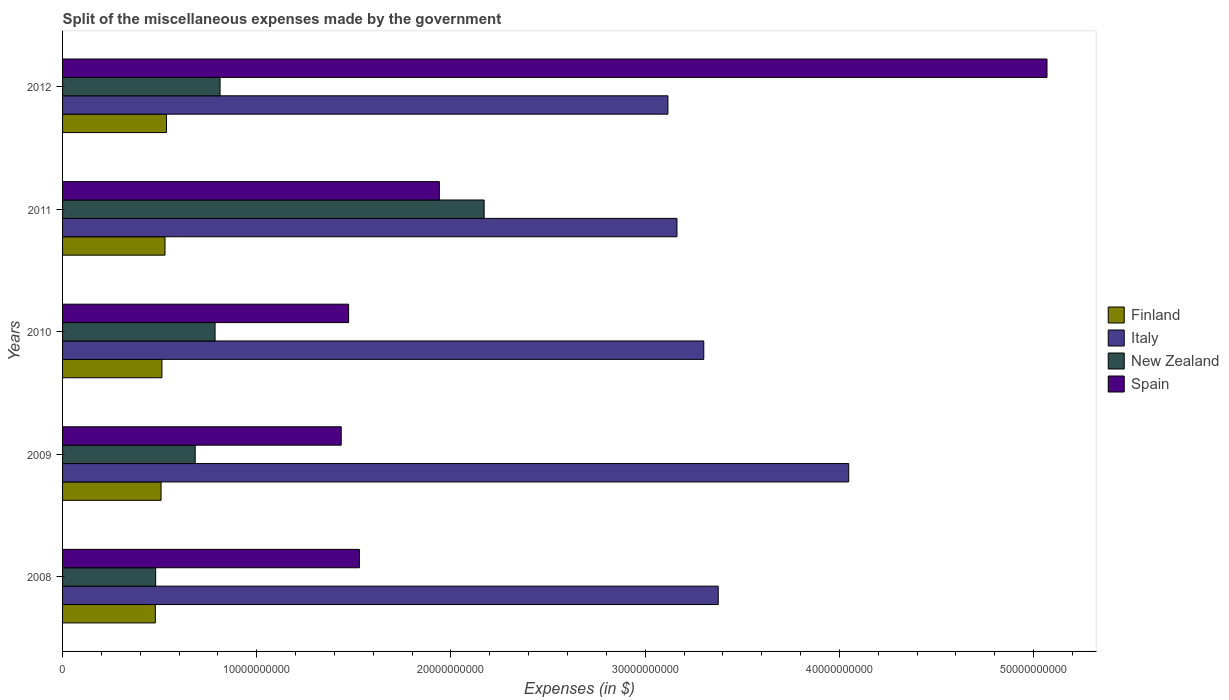How many different coloured bars are there?
Your answer should be compact. 4. How many groups of bars are there?
Your answer should be very brief. 5. Are the number of bars on each tick of the Y-axis equal?
Ensure brevity in your answer.  Yes. How many bars are there on the 1st tick from the top?
Offer a very short reply. 4. How many bars are there on the 3rd tick from the bottom?
Offer a terse response. 4. What is the label of the 2nd group of bars from the top?
Offer a terse response. 2011. What is the miscellaneous expenses made by the government in Italy in 2011?
Ensure brevity in your answer.  3.16e+1. Across all years, what is the maximum miscellaneous expenses made by the government in Spain?
Provide a short and direct response. 5.07e+1. Across all years, what is the minimum miscellaneous expenses made by the government in New Zealand?
Provide a succinct answer. 4.79e+09. What is the total miscellaneous expenses made by the government in Italy in the graph?
Offer a terse response. 1.70e+11. What is the difference between the miscellaneous expenses made by the government in Finland in 2008 and that in 2012?
Your response must be concise. -5.75e+08. What is the difference between the miscellaneous expenses made by the government in Italy in 2010 and the miscellaneous expenses made by the government in Finland in 2009?
Keep it short and to the point. 2.79e+1. What is the average miscellaneous expenses made by the government in New Zealand per year?
Offer a very short reply. 9.86e+09. In the year 2012, what is the difference between the miscellaneous expenses made by the government in Spain and miscellaneous expenses made by the government in New Zealand?
Your answer should be compact. 4.26e+1. What is the ratio of the miscellaneous expenses made by the government in Finland in 2010 to that in 2012?
Your answer should be compact. 0.96. Is the miscellaneous expenses made by the government in Finland in 2010 less than that in 2011?
Ensure brevity in your answer.  Yes. What is the difference between the highest and the second highest miscellaneous expenses made by the government in New Zealand?
Give a very brief answer. 1.36e+1. What is the difference between the highest and the lowest miscellaneous expenses made by the government in Spain?
Make the answer very short. 3.63e+1. Is the sum of the miscellaneous expenses made by the government in Spain in 2008 and 2011 greater than the maximum miscellaneous expenses made by the government in New Zealand across all years?
Your response must be concise. Yes. What does the 2nd bar from the top in 2008 represents?
Give a very brief answer. New Zealand. Is it the case that in every year, the sum of the miscellaneous expenses made by the government in Spain and miscellaneous expenses made by the government in Finland is greater than the miscellaneous expenses made by the government in Italy?
Keep it short and to the point. No. How many years are there in the graph?
Provide a short and direct response. 5. What is the difference between two consecutive major ticks on the X-axis?
Give a very brief answer. 1.00e+1. Are the values on the major ticks of X-axis written in scientific E-notation?
Ensure brevity in your answer.  No. Does the graph contain grids?
Keep it short and to the point. No. How many legend labels are there?
Give a very brief answer. 4. What is the title of the graph?
Your answer should be compact. Split of the miscellaneous expenses made by the government. What is the label or title of the X-axis?
Give a very brief answer. Expenses (in $). What is the Expenses (in $) in Finland in 2008?
Offer a very short reply. 4.78e+09. What is the Expenses (in $) of Italy in 2008?
Your answer should be compact. 3.38e+1. What is the Expenses (in $) of New Zealand in 2008?
Your answer should be very brief. 4.79e+09. What is the Expenses (in $) of Spain in 2008?
Provide a succinct answer. 1.53e+1. What is the Expenses (in $) of Finland in 2009?
Provide a short and direct response. 5.07e+09. What is the Expenses (in $) of Italy in 2009?
Offer a terse response. 4.05e+1. What is the Expenses (in $) of New Zealand in 2009?
Your answer should be compact. 6.83e+09. What is the Expenses (in $) of Spain in 2009?
Your response must be concise. 1.43e+1. What is the Expenses (in $) in Finland in 2010?
Your response must be concise. 5.12e+09. What is the Expenses (in $) in Italy in 2010?
Your answer should be compact. 3.30e+1. What is the Expenses (in $) of New Zealand in 2010?
Keep it short and to the point. 7.85e+09. What is the Expenses (in $) in Spain in 2010?
Your answer should be compact. 1.47e+1. What is the Expenses (in $) in Finland in 2011?
Make the answer very short. 5.28e+09. What is the Expenses (in $) in Italy in 2011?
Give a very brief answer. 3.16e+1. What is the Expenses (in $) of New Zealand in 2011?
Keep it short and to the point. 2.17e+1. What is the Expenses (in $) in Spain in 2011?
Ensure brevity in your answer.  1.94e+1. What is the Expenses (in $) of Finland in 2012?
Your answer should be compact. 5.35e+09. What is the Expenses (in $) in Italy in 2012?
Your answer should be compact. 3.12e+1. What is the Expenses (in $) of New Zealand in 2012?
Offer a very short reply. 8.11e+09. What is the Expenses (in $) in Spain in 2012?
Offer a terse response. 5.07e+1. Across all years, what is the maximum Expenses (in $) in Finland?
Offer a very short reply. 5.35e+09. Across all years, what is the maximum Expenses (in $) in Italy?
Give a very brief answer. 4.05e+1. Across all years, what is the maximum Expenses (in $) in New Zealand?
Give a very brief answer. 2.17e+1. Across all years, what is the maximum Expenses (in $) in Spain?
Make the answer very short. 5.07e+1. Across all years, what is the minimum Expenses (in $) in Finland?
Your answer should be very brief. 4.78e+09. Across all years, what is the minimum Expenses (in $) of Italy?
Your answer should be compact. 3.12e+1. Across all years, what is the minimum Expenses (in $) of New Zealand?
Provide a succinct answer. 4.79e+09. Across all years, what is the minimum Expenses (in $) in Spain?
Ensure brevity in your answer.  1.43e+1. What is the total Expenses (in $) of Finland in the graph?
Provide a short and direct response. 2.56e+1. What is the total Expenses (in $) in Italy in the graph?
Your answer should be very brief. 1.70e+11. What is the total Expenses (in $) in New Zealand in the graph?
Offer a very short reply. 4.93e+1. What is the total Expenses (in $) of Spain in the graph?
Your answer should be compact. 1.14e+11. What is the difference between the Expenses (in $) of Finland in 2008 and that in 2009?
Provide a short and direct response. -2.94e+08. What is the difference between the Expenses (in $) of Italy in 2008 and that in 2009?
Give a very brief answer. -6.72e+09. What is the difference between the Expenses (in $) of New Zealand in 2008 and that in 2009?
Make the answer very short. -2.04e+09. What is the difference between the Expenses (in $) in Spain in 2008 and that in 2009?
Your response must be concise. 9.39e+08. What is the difference between the Expenses (in $) of Finland in 2008 and that in 2010?
Offer a very short reply. -3.39e+08. What is the difference between the Expenses (in $) in Italy in 2008 and that in 2010?
Offer a terse response. 7.45e+08. What is the difference between the Expenses (in $) of New Zealand in 2008 and that in 2010?
Give a very brief answer. -3.06e+09. What is the difference between the Expenses (in $) of Spain in 2008 and that in 2010?
Your answer should be compact. 5.57e+08. What is the difference between the Expenses (in $) in Finland in 2008 and that in 2011?
Provide a succinct answer. -4.97e+08. What is the difference between the Expenses (in $) in Italy in 2008 and that in 2011?
Your answer should be compact. 2.12e+09. What is the difference between the Expenses (in $) in New Zealand in 2008 and that in 2011?
Your answer should be compact. -1.69e+1. What is the difference between the Expenses (in $) in Spain in 2008 and that in 2011?
Provide a succinct answer. -4.12e+09. What is the difference between the Expenses (in $) in Finland in 2008 and that in 2012?
Offer a terse response. -5.75e+08. What is the difference between the Expenses (in $) of Italy in 2008 and that in 2012?
Keep it short and to the point. 2.59e+09. What is the difference between the Expenses (in $) of New Zealand in 2008 and that in 2012?
Give a very brief answer. -3.32e+09. What is the difference between the Expenses (in $) of Spain in 2008 and that in 2012?
Provide a succinct answer. -3.54e+1. What is the difference between the Expenses (in $) in Finland in 2009 and that in 2010?
Give a very brief answer. -4.50e+07. What is the difference between the Expenses (in $) in Italy in 2009 and that in 2010?
Give a very brief answer. 7.46e+09. What is the difference between the Expenses (in $) in New Zealand in 2009 and that in 2010?
Provide a short and direct response. -1.02e+09. What is the difference between the Expenses (in $) of Spain in 2009 and that in 2010?
Offer a very short reply. -3.82e+08. What is the difference between the Expenses (in $) of Finland in 2009 and that in 2011?
Make the answer very short. -2.03e+08. What is the difference between the Expenses (in $) in Italy in 2009 and that in 2011?
Offer a very short reply. 8.84e+09. What is the difference between the Expenses (in $) in New Zealand in 2009 and that in 2011?
Your response must be concise. -1.49e+1. What is the difference between the Expenses (in $) of Spain in 2009 and that in 2011?
Provide a succinct answer. -5.06e+09. What is the difference between the Expenses (in $) of Finland in 2009 and that in 2012?
Provide a succinct answer. -2.81e+08. What is the difference between the Expenses (in $) in Italy in 2009 and that in 2012?
Your response must be concise. 9.31e+09. What is the difference between the Expenses (in $) of New Zealand in 2009 and that in 2012?
Your answer should be compact. -1.28e+09. What is the difference between the Expenses (in $) in Spain in 2009 and that in 2012?
Provide a short and direct response. -3.63e+1. What is the difference between the Expenses (in $) in Finland in 2010 and that in 2011?
Offer a terse response. -1.58e+08. What is the difference between the Expenses (in $) in Italy in 2010 and that in 2011?
Give a very brief answer. 1.38e+09. What is the difference between the Expenses (in $) in New Zealand in 2010 and that in 2011?
Ensure brevity in your answer.  -1.39e+1. What is the difference between the Expenses (in $) in Spain in 2010 and that in 2011?
Provide a short and direct response. -4.67e+09. What is the difference between the Expenses (in $) of Finland in 2010 and that in 2012?
Keep it short and to the point. -2.36e+08. What is the difference between the Expenses (in $) of Italy in 2010 and that in 2012?
Your answer should be very brief. 1.85e+09. What is the difference between the Expenses (in $) in New Zealand in 2010 and that in 2012?
Your response must be concise. -2.58e+08. What is the difference between the Expenses (in $) in Spain in 2010 and that in 2012?
Ensure brevity in your answer.  -3.60e+1. What is the difference between the Expenses (in $) of Finland in 2011 and that in 2012?
Your answer should be compact. -7.80e+07. What is the difference between the Expenses (in $) of Italy in 2011 and that in 2012?
Ensure brevity in your answer.  4.66e+08. What is the difference between the Expenses (in $) in New Zealand in 2011 and that in 2012?
Ensure brevity in your answer.  1.36e+1. What is the difference between the Expenses (in $) in Spain in 2011 and that in 2012?
Ensure brevity in your answer.  -3.13e+1. What is the difference between the Expenses (in $) in Finland in 2008 and the Expenses (in $) in Italy in 2009?
Offer a very short reply. -3.57e+1. What is the difference between the Expenses (in $) in Finland in 2008 and the Expenses (in $) in New Zealand in 2009?
Provide a short and direct response. -2.05e+09. What is the difference between the Expenses (in $) of Finland in 2008 and the Expenses (in $) of Spain in 2009?
Keep it short and to the point. -9.57e+09. What is the difference between the Expenses (in $) in Italy in 2008 and the Expenses (in $) in New Zealand in 2009?
Ensure brevity in your answer.  2.69e+1. What is the difference between the Expenses (in $) in Italy in 2008 and the Expenses (in $) in Spain in 2009?
Make the answer very short. 1.94e+1. What is the difference between the Expenses (in $) in New Zealand in 2008 and the Expenses (in $) in Spain in 2009?
Ensure brevity in your answer.  -9.55e+09. What is the difference between the Expenses (in $) in Finland in 2008 and the Expenses (in $) in Italy in 2010?
Offer a terse response. -2.82e+1. What is the difference between the Expenses (in $) of Finland in 2008 and the Expenses (in $) of New Zealand in 2010?
Make the answer very short. -3.07e+09. What is the difference between the Expenses (in $) in Finland in 2008 and the Expenses (in $) in Spain in 2010?
Make the answer very short. -9.95e+09. What is the difference between the Expenses (in $) of Italy in 2008 and the Expenses (in $) of New Zealand in 2010?
Provide a succinct answer. 2.59e+1. What is the difference between the Expenses (in $) in Italy in 2008 and the Expenses (in $) in Spain in 2010?
Offer a terse response. 1.90e+1. What is the difference between the Expenses (in $) of New Zealand in 2008 and the Expenses (in $) of Spain in 2010?
Your answer should be very brief. -9.94e+09. What is the difference between the Expenses (in $) of Finland in 2008 and the Expenses (in $) of Italy in 2011?
Your response must be concise. -2.69e+1. What is the difference between the Expenses (in $) in Finland in 2008 and the Expenses (in $) in New Zealand in 2011?
Your answer should be compact. -1.69e+1. What is the difference between the Expenses (in $) of Finland in 2008 and the Expenses (in $) of Spain in 2011?
Provide a short and direct response. -1.46e+1. What is the difference between the Expenses (in $) of Italy in 2008 and the Expenses (in $) of New Zealand in 2011?
Keep it short and to the point. 1.21e+1. What is the difference between the Expenses (in $) of Italy in 2008 and the Expenses (in $) of Spain in 2011?
Offer a terse response. 1.44e+1. What is the difference between the Expenses (in $) of New Zealand in 2008 and the Expenses (in $) of Spain in 2011?
Keep it short and to the point. -1.46e+1. What is the difference between the Expenses (in $) in Finland in 2008 and the Expenses (in $) in Italy in 2012?
Give a very brief answer. -2.64e+1. What is the difference between the Expenses (in $) of Finland in 2008 and the Expenses (in $) of New Zealand in 2012?
Keep it short and to the point. -3.33e+09. What is the difference between the Expenses (in $) of Finland in 2008 and the Expenses (in $) of Spain in 2012?
Offer a terse response. -4.59e+1. What is the difference between the Expenses (in $) of Italy in 2008 and the Expenses (in $) of New Zealand in 2012?
Provide a succinct answer. 2.57e+1. What is the difference between the Expenses (in $) of Italy in 2008 and the Expenses (in $) of Spain in 2012?
Provide a short and direct response. -1.69e+1. What is the difference between the Expenses (in $) in New Zealand in 2008 and the Expenses (in $) in Spain in 2012?
Make the answer very short. -4.59e+1. What is the difference between the Expenses (in $) in Finland in 2009 and the Expenses (in $) in Italy in 2010?
Your response must be concise. -2.79e+1. What is the difference between the Expenses (in $) of Finland in 2009 and the Expenses (in $) of New Zealand in 2010?
Make the answer very short. -2.78e+09. What is the difference between the Expenses (in $) in Finland in 2009 and the Expenses (in $) in Spain in 2010?
Make the answer very short. -9.66e+09. What is the difference between the Expenses (in $) of Italy in 2009 and the Expenses (in $) of New Zealand in 2010?
Ensure brevity in your answer.  3.26e+1. What is the difference between the Expenses (in $) of Italy in 2009 and the Expenses (in $) of Spain in 2010?
Offer a very short reply. 2.58e+1. What is the difference between the Expenses (in $) of New Zealand in 2009 and the Expenses (in $) of Spain in 2010?
Your response must be concise. -7.90e+09. What is the difference between the Expenses (in $) in Finland in 2009 and the Expenses (in $) in Italy in 2011?
Your answer should be very brief. -2.66e+1. What is the difference between the Expenses (in $) in Finland in 2009 and the Expenses (in $) in New Zealand in 2011?
Give a very brief answer. -1.66e+1. What is the difference between the Expenses (in $) in Finland in 2009 and the Expenses (in $) in Spain in 2011?
Ensure brevity in your answer.  -1.43e+1. What is the difference between the Expenses (in $) of Italy in 2009 and the Expenses (in $) of New Zealand in 2011?
Make the answer very short. 1.88e+1. What is the difference between the Expenses (in $) of Italy in 2009 and the Expenses (in $) of Spain in 2011?
Keep it short and to the point. 2.11e+1. What is the difference between the Expenses (in $) of New Zealand in 2009 and the Expenses (in $) of Spain in 2011?
Give a very brief answer. -1.26e+1. What is the difference between the Expenses (in $) of Finland in 2009 and the Expenses (in $) of Italy in 2012?
Offer a very short reply. -2.61e+1. What is the difference between the Expenses (in $) in Finland in 2009 and the Expenses (in $) in New Zealand in 2012?
Give a very brief answer. -3.04e+09. What is the difference between the Expenses (in $) in Finland in 2009 and the Expenses (in $) in Spain in 2012?
Offer a terse response. -4.56e+1. What is the difference between the Expenses (in $) of Italy in 2009 and the Expenses (in $) of New Zealand in 2012?
Your answer should be very brief. 3.24e+1. What is the difference between the Expenses (in $) of Italy in 2009 and the Expenses (in $) of Spain in 2012?
Your response must be concise. -1.02e+1. What is the difference between the Expenses (in $) in New Zealand in 2009 and the Expenses (in $) in Spain in 2012?
Your answer should be very brief. -4.39e+1. What is the difference between the Expenses (in $) in Finland in 2010 and the Expenses (in $) in Italy in 2011?
Provide a succinct answer. -2.65e+1. What is the difference between the Expenses (in $) of Finland in 2010 and the Expenses (in $) of New Zealand in 2011?
Provide a succinct answer. -1.66e+1. What is the difference between the Expenses (in $) of Finland in 2010 and the Expenses (in $) of Spain in 2011?
Provide a short and direct response. -1.43e+1. What is the difference between the Expenses (in $) in Italy in 2010 and the Expenses (in $) in New Zealand in 2011?
Your response must be concise. 1.13e+1. What is the difference between the Expenses (in $) of Italy in 2010 and the Expenses (in $) of Spain in 2011?
Ensure brevity in your answer.  1.36e+1. What is the difference between the Expenses (in $) in New Zealand in 2010 and the Expenses (in $) in Spain in 2011?
Make the answer very short. -1.16e+1. What is the difference between the Expenses (in $) in Finland in 2010 and the Expenses (in $) in Italy in 2012?
Provide a succinct answer. -2.61e+1. What is the difference between the Expenses (in $) in Finland in 2010 and the Expenses (in $) in New Zealand in 2012?
Make the answer very short. -2.99e+09. What is the difference between the Expenses (in $) in Finland in 2010 and the Expenses (in $) in Spain in 2012?
Make the answer very short. -4.56e+1. What is the difference between the Expenses (in $) in Italy in 2010 and the Expenses (in $) in New Zealand in 2012?
Offer a terse response. 2.49e+1. What is the difference between the Expenses (in $) of Italy in 2010 and the Expenses (in $) of Spain in 2012?
Offer a very short reply. -1.77e+1. What is the difference between the Expenses (in $) in New Zealand in 2010 and the Expenses (in $) in Spain in 2012?
Your answer should be compact. -4.28e+1. What is the difference between the Expenses (in $) in Finland in 2011 and the Expenses (in $) in Italy in 2012?
Offer a very short reply. -2.59e+1. What is the difference between the Expenses (in $) of Finland in 2011 and the Expenses (in $) of New Zealand in 2012?
Your answer should be very brief. -2.83e+09. What is the difference between the Expenses (in $) of Finland in 2011 and the Expenses (in $) of Spain in 2012?
Your answer should be very brief. -4.54e+1. What is the difference between the Expenses (in $) in Italy in 2011 and the Expenses (in $) in New Zealand in 2012?
Your answer should be compact. 2.35e+1. What is the difference between the Expenses (in $) in Italy in 2011 and the Expenses (in $) in Spain in 2012?
Provide a succinct answer. -1.91e+1. What is the difference between the Expenses (in $) in New Zealand in 2011 and the Expenses (in $) in Spain in 2012?
Ensure brevity in your answer.  -2.90e+1. What is the average Expenses (in $) in Finland per year?
Your answer should be compact. 5.12e+09. What is the average Expenses (in $) in Italy per year?
Make the answer very short. 3.40e+1. What is the average Expenses (in $) of New Zealand per year?
Your answer should be very brief. 9.86e+09. What is the average Expenses (in $) in Spain per year?
Provide a succinct answer. 2.29e+1. In the year 2008, what is the difference between the Expenses (in $) of Finland and Expenses (in $) of Italy?
Offer a terse response. -2.90e+1. In the year 2008, what is the difference between the Expenses (in $) in Finland and Expenses (in $) in New Zealand?
Make the answer very short. -1.55e+07. In the year 2008, what is the difference between the Expenses (in $) of Finland and Expenses (in $) of Spain?
Provide a succinct answer. -1.05e+1. In the year 2008, what is the difference between the Expenses (in $) of Italy and Expenses (in $) of New Zealand?
Keep it short and to the point. 2.90e+1. In the year 2008, what is the difference between the Expenses (in $) of Italy and Expenses (in $) of Spain?
Your answer should be compact. 1.85e+1. In the year 2008, what is the difference between the Expenses (in $) in New Zealand and Expenses (in $) in Spain?
Make the answer very short. -1.05e+1. In the year 2009, what is the difference between the Expenses (in $) of Finland and Expenses (in $) of Italy?
Offer a very short reply. -3.54e+1. In the year 2009, what is the difference between the Expenses (in $) in Finland and Expenses (in $) in New Zealand?
Your answer should be compact. -1.76e+09. In the year 2009, what is the difference between the Expenses (in $) of Finland and Expenses (in $) of Spain?
Your answer should be very brief. -9.28e+09. In the year 2009, what is the difference between the Expenses (in $) in Italy and Expenses (in $) in New Zealand?
Provide a short and direct response. 3.37e+1. In the year 2009, what is the difference between the Expenses (in $) in Italy and Expenses (in $) in Spain?
Your answer should be compact. 2.61e+1. In the year 2009, what is the difference between the Expenses (in $) in New Zealand and Expenses (in $) in Spain?
Offer a very short reply. -7.52e+09. In the year 2010, what is the difference between the Expenses (in $) of Finland and Expenses (in $) of Italy?
Provide a short and direct response. -2.79e+1. In the year 2010, what is the difference between the Expenses (in $) of Finland and Expenses (in $) of New Zealand?
Give a very brief answer. -2.74e+09. In the year 2010, what is the difference between the Expenses (in $) in Finland and Expenses (in $) in Spain?
Provide a short and direct response. -9.61e+09. In the year 2010, what is the difference between the Expenses (in $) of Italy and Expenses (in $) of New Zealand?
Offer a terse response. 2.52e+1. In the year 2010, what is the difference between the Expenses (in $) in Italy and Expenses (in $) in Spain?
Provide a succinct answer. 1.83e+1. In the year 2010, what is the difference between the Expenses (in $) of New Zealand and Expenses (in $) of Spain?
Keep it short and to the point. -6.88e+09. In the year 2011, what is the difference between the Expenses (in $) of Finland and Expenses (in $) of Italy?
Offer a very short reply. -2.64e+1. In the year 2011, what is the difference between the Expenses (in $) of Finland and Expenses (in $) of New Zealand?
Your answer should be very brief. -1.64e+1. In the year 2011, what is the difference between the Expenses (in $) in Finland and Expenses (in $) in Spain?
Ensure brevity in your answer.  -1.41e+1. In the year 2011, what is the difference between the Expenses (in $) of Italy and Expenses (in $) of New Zealand?
Your response must be concise. 9.93e+09. In the year 2011, what is the difference between the Expenses (in $) in Italy and Expenses (in $) in Spain?
Provide a succinct answer. 1.22e+1. In the year 2011, what is the difference between the Expenses (in $) in New Zealand and Expenses (in $) in Spain?
Keep it short and to the point. 2.31e+09. In the year 2012, what is the difference between the Expenses (in $) of Finland and Expenses (in $) of Italy?
Your response must be concise. -2.58e+1. In the year 2012, what is the difference between the Expenses (in $) of Finland and Expenses (in $) of New Zealand?
Your response must be concise. -2.76e+09. In the year 2012, what is the difference between the Expenses (in $) of Finland and Expenses (in $) of Spain?
Offer a terse response. -4.53e+1. In the year 2012, what is the difference between the Expenses (in $) of Italy and Expenses (in $) of New Zealand?
Ensure brevity in your answer.  2.31e+1. In the year 2012, what is the difference between the Expenses (in $) of Italy and Expenses (in $) of Spain?
Your answer should be compact. -1.95e+1. In the year 2012, what is the difference between the Expenses (in $) in New Zealand and Expenses (in $) in Spain?
Offer a very short reply. -4.26e+1. What is the ratio of the Expenses (in $) of Finland in 2008 to that in 2009?
Make the answer very short. 0.94. What is the ratio of the Expenses (in $) of Italy in 2008 to that in 2009?
Your answer should be very brief. 0.83. What is the ratio of the Expenses (in $) of New Zealand in 2008 to that in 2009?
Your answer should be very brief. 0.7. What is the ratio of the Expenses (in $) in Spain in 2008 to that in 2009?
Ensure brevity in your answer.  1.07. What is the ratio of the Expenses (in $) of Finland in 2008 to that in 2010?
Give a very brief answer. 0.93. What is the ratio of the Expenses (in $) in Italy in 2008 to that in 2010?
Ensure brevity in your answer.  1.02. What is the ratio of the Expenses (in $) of New Zealand in 2008 to that in 2010?
Your response must be concise. 0.61. What is the ratio of the Expenses (in $) of Spain in 2008 to that in 2010?
Provide a short and direct response. 1.04. What is the ratio of the Expenses (in $) in Finland in 2008 to that in 2011?
Make the answer very short. 0.91. What is the ratio of the Expenses (in $) in Italy in 2008 to that in 2011?
Your response must be concise. 1.07. What is the ratio of the Expenses (in $) of New Zealand in 2008 to that in 2011?
Your answer should be very brief. 0.22. What is the ratio of the Expenses (in $) in Spain in 2008 to that in 2011?
Your response must be concise. 0.79. What is the ratio of the Expenses (in $) of Finland in 2008 to that in 2012?
Make the answer very short. 0.89. What is the ratio of the Expenses (in $) of Italy in 2008 to that in 2012?
Give a very brief answer. 1.08. What is the ratio of the Expenses (in $) in New Zealand in 2008 to that in 2012?
Keep it short and to the point. 0.59. What is the ratio of the Expenses (in $) of Spain in 2008 to that in 2012?
Give a very brief answer. 0.3. What is the ratio of the Expenses (in $) of Italy in 2009 to that in 2010?
Your answer should be very brief. 1.23. What is the ratio of the Expenses (in $) of New Zealand in 2009 to that in 2010?
Your answer should be compact. 0.87. What is the ratio of the Expenses (in $) in Spain in 2009 to that in 2010?
Offer a terse response. 0.97. What is the ratio of the Expenses (in $) of Finland in 2009 to that in 2011?
Offer a very short reply. 0.96. What is the ratio of the Expenses (in $) of Italy in 2009 to that in 2011?
Keep it short and to the point. 1.28. What is the ratio of the Expenses (in $) of New Zealand in 2009 to that in 2011?
Your answer should be compact. 0.31. What is the ratio of the Expenses (in $) of Spain in 2009 to that in 2011?
Provide a short and direct response. 0.74. What is the ratio of the Expenses (in $) in Finland in 2009 to that in 2012?
Your answer should be very brief. 0.95. What is the ratio of the Expenses (in $) of Italy in 2009 to that in 2012?
Offer a terse response. 1.3. What is the ratio of the Expenses (in $) in New Zealand in 2009 to that in 2012?
Your answer should be very brief. 0.84. What is the ratio of the Expenses (in $) of Spain in 2009 to that in 2012?
Provide a succinct answer. 0.28. What is the ratio of the Expenses (in $) of Italy in 2010 to that in 2011?
Provide a succinct answer. 1.04. What is the ratio of the Expenses (in $) in New Zealand in 2010 to that in 2011?
Provide a short and direct response. 0.36. What is the ratio of the Expenses (in $) of Spain in 2010 to that in 2011?
Your answer should be compact. 0.76. What is the ratio of the Expenses (in $) in Finland in 2010 to that in 2012?
Offer a very short reply. 0.96. What is the ratio of the Expenses (in $) of Italy in 2010 to that in 2012?
Offer a terse response. 1.06. What is the ratio of the Expenses (in $) of New Zealand in 2010 to that in 2012?
Keep it short and to the point. 0.97. What is the ratio of the Expenses (in $) in Spain in 2010 to that in 2012?
Your answer should be very brief. 0.29. What is the ratio of the Expenses (in $) of Finland in 2011 to that in 2012?
Provide a short and direct response. 0.99. What is the ratio of the Expenses (in $) of Italy in 2011 to that in 2012?
Your answer should be very brief. 1.01. What is the ratio of the Expenses (in $) in New Zealand in 2011 to that in 2012?
Your answer should be compact. 2.68. What is the ratio of the Expenses (in $) in Spain in 2011 to that in 2012?
Offer a very short reply. 0.38. What is the difference between the highest and the second highest Expenses (in $) in Finland?
Provide a short and direct response. 7.80e+07. What is the difference between the highest and the second highest Expenses (in $) in Italy?
Offer a terse response. 6.72e+09. What is the difference between the highest and the second highest Expenses (in $) in New Zealand?
Your response must be concise. 1.36e+1. What is the difference between the highest and the second highest Expenses (in $) of Spain?
Your answer should be compact. 3.13e+1. What is the difference between the highest and the lowest Expenses (in $) of Finland?
Offer a terse response. 5.75e+08. What is the difference between the highest and the lowest Expenses (in $) of Italy?
Provide a succinct answer. 9.31e+09. What is the difference between the highest and the lowest Expenses (in $) of New Zealand?
Ensure brevity in your answer.  1.69e+1. What is the difference between the highest and the lowest Expenses (in $) in Spain?
Provide a short and direct response. 3.63e+1. 